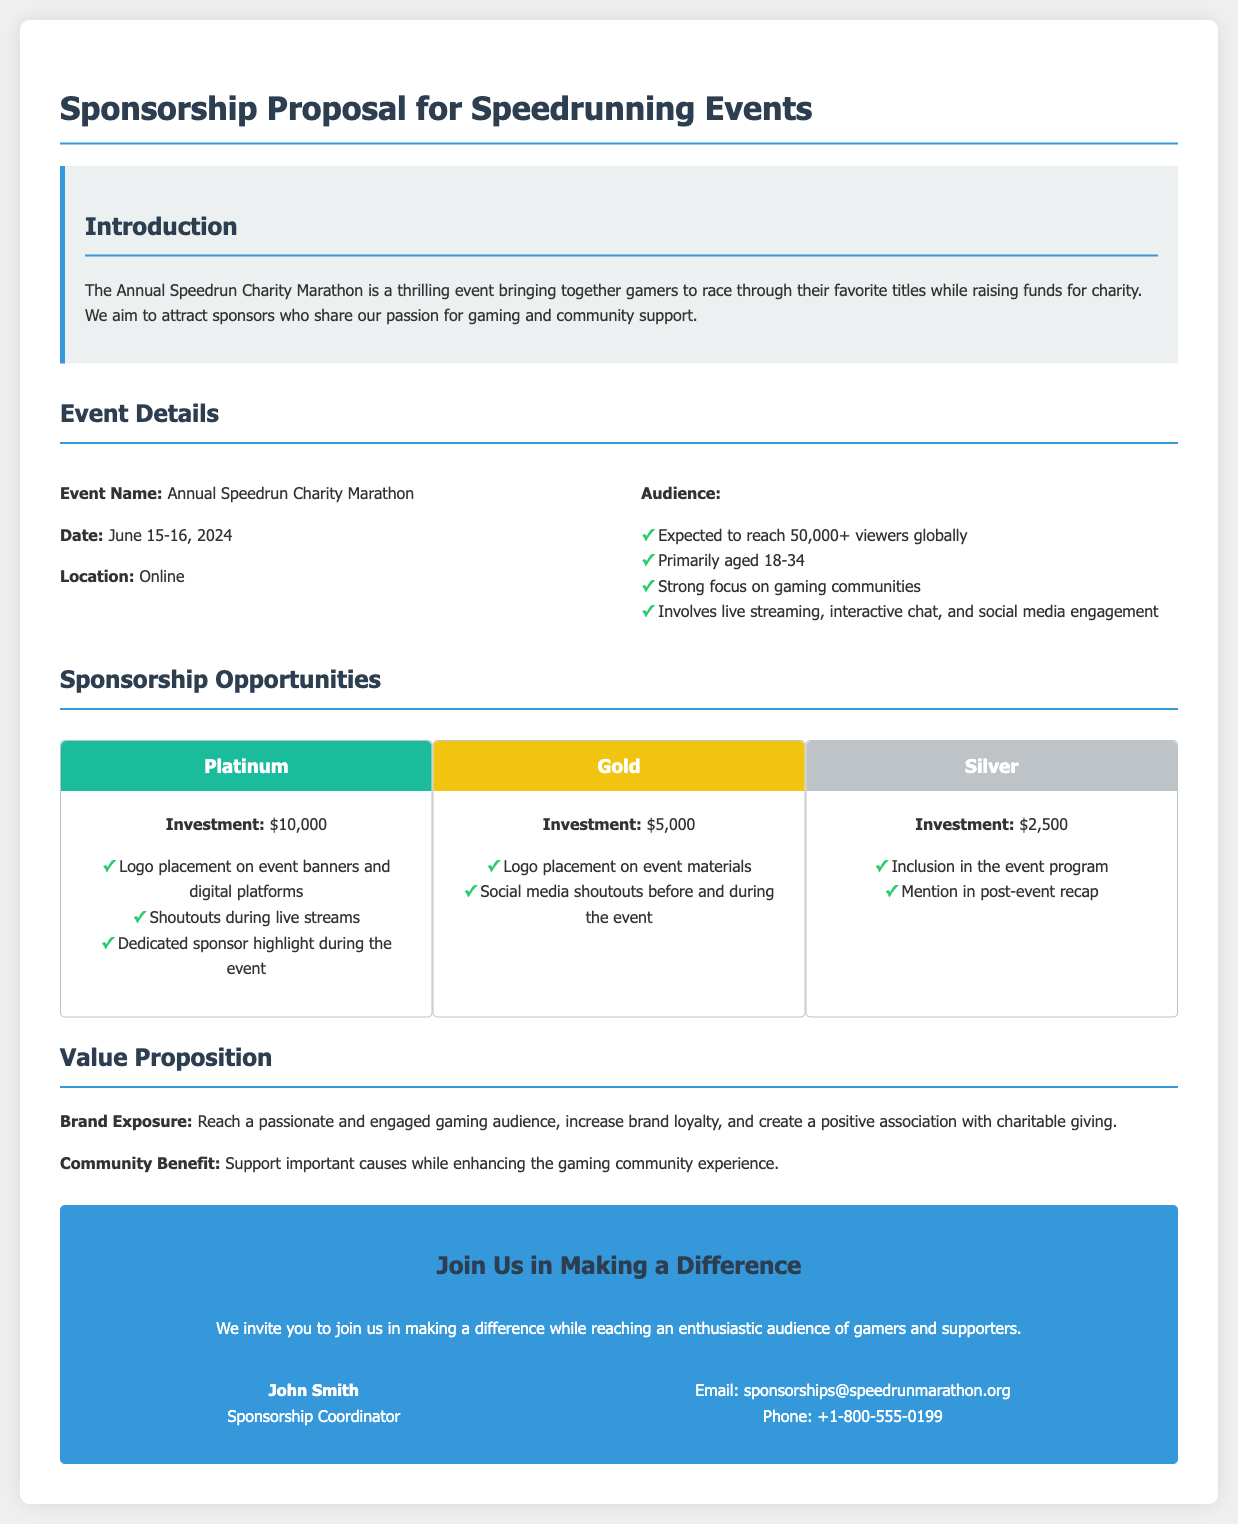What is the event name? The event name is specified in the document under "Event Name."
Answer: Annual Speedrun Charity Marathon When is the event scheduled? The document provides the date in the "Date" section.
Answer: June 15-16, 2024 What is the expected viewer reach? The document states this information in the "Audience" subsection.
Answer: 50,000+ What is the investment amount for the Platinum level? The investment amount is detailed under "Sponsorship Opportunities" for each level.
Answer: $10,000 What are the benefits of the Gold sponsorship? This requires reasoning over the sponsorship details provided in the document.
Answer: Logo placement on event materials and social media shoutouts What section contains the value proposition? The document outlines the value proposition in a specific section after sponsorship levels.
Answer: Value Proposition Who is the contact person for sponsorship inquiries? The contact person is mentioned in the call to action section.
Answer: John Smith What support does the event aim to provide? The document mentions the aim of supporting causes in the value proposition.
Answer: Charitable giving 